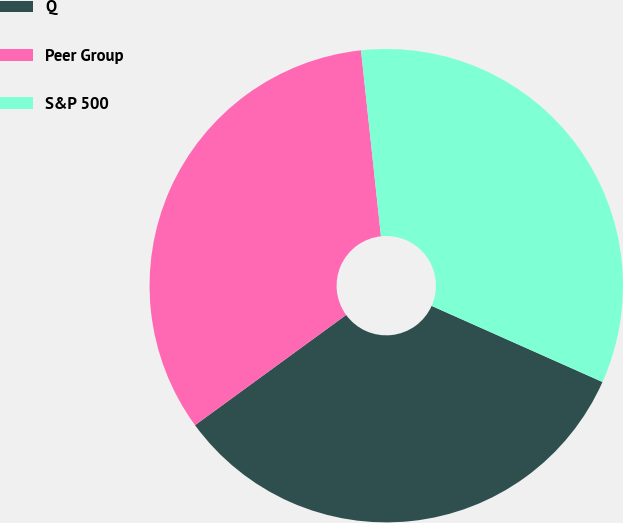Convert chart. <chart><loc_0><loc_0><loc_500><loc_500><pie_chart><fcel>Q<fcel>Peer Group<fcel>S&P 500<nl><fcel>33.3%<fcel>33.33%<fcel>33.37%<nl></chart> 